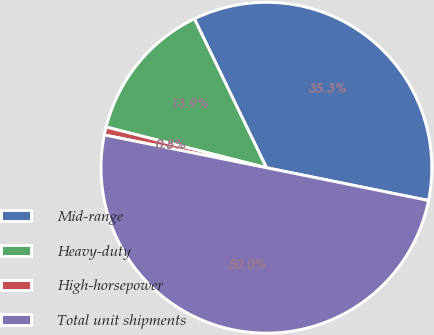<chart> <loc_0><loc_0><loc_500><loc_500><pie_chart><fcel>Mid-range<fcel>Heavy-duty<fcel>High-horsepower<fcel>Total unit shipments<nl><fcel>35.35%<fcel>13.87%<fcel>0.78%<fcel>50.0%<nl></chart> 